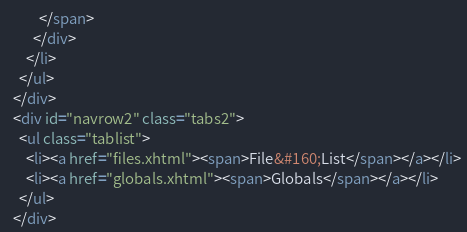<code> <loc_0><loc_0><loc_500><loc_500><_HTML_>          </span>
        </div>
      </li>
    </ul>
  </div>
  <div id="navrow2" class="tabs2">
    <ul class="tablist">
      <li><a href="files.xhtml"><span>File&#160;List</span></a></li>
      <li><a href="globals.xhtml"><span>Globals</span></a></li>
    </ul>
  </div></code> 